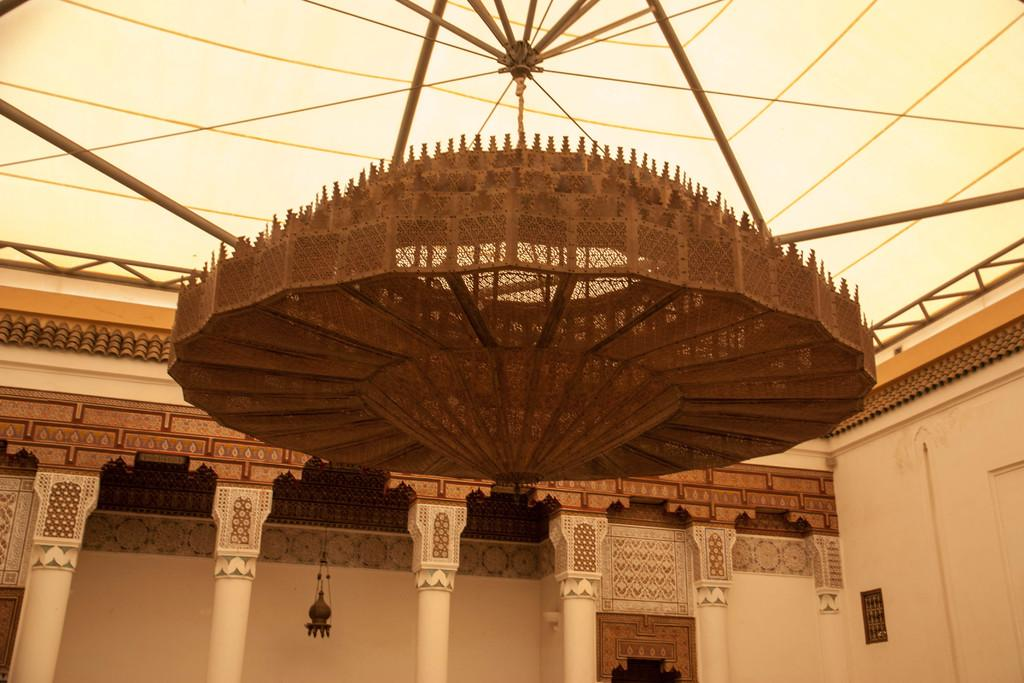Where was the image taken? The image is taken inside a building. What architectural features can be seen in the image? There are pillars in the image. What type of lighting fixture is present in the image? There is a chandelier in the image. What part of the building is visible in the image? The roof is visible in the image. What kind of design can be seen on the walls in the image? There is a design on the walls in the image. Reasoning: Let' Let's think step by step in order to produce the conversation. We start by identifying the location of the image, which is inside a building. Then, we describe the architectural features and other elements present in the image, such as pillars, a chandelier, the roof, and the design on the walls. Each question is designed to elicit a specific detail about the image that is known from the provided facts. Absurd Question/Answer: What type of loaf is being used as a decoration on the chandelier in the image? There is no loaf present in the image, and the chandelier is not being used as a decoration. 